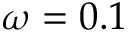Convert formula to latex. <formula><loc_0><loc_0><loc_500><loc_500>\omega = 0 . 1</formula> 